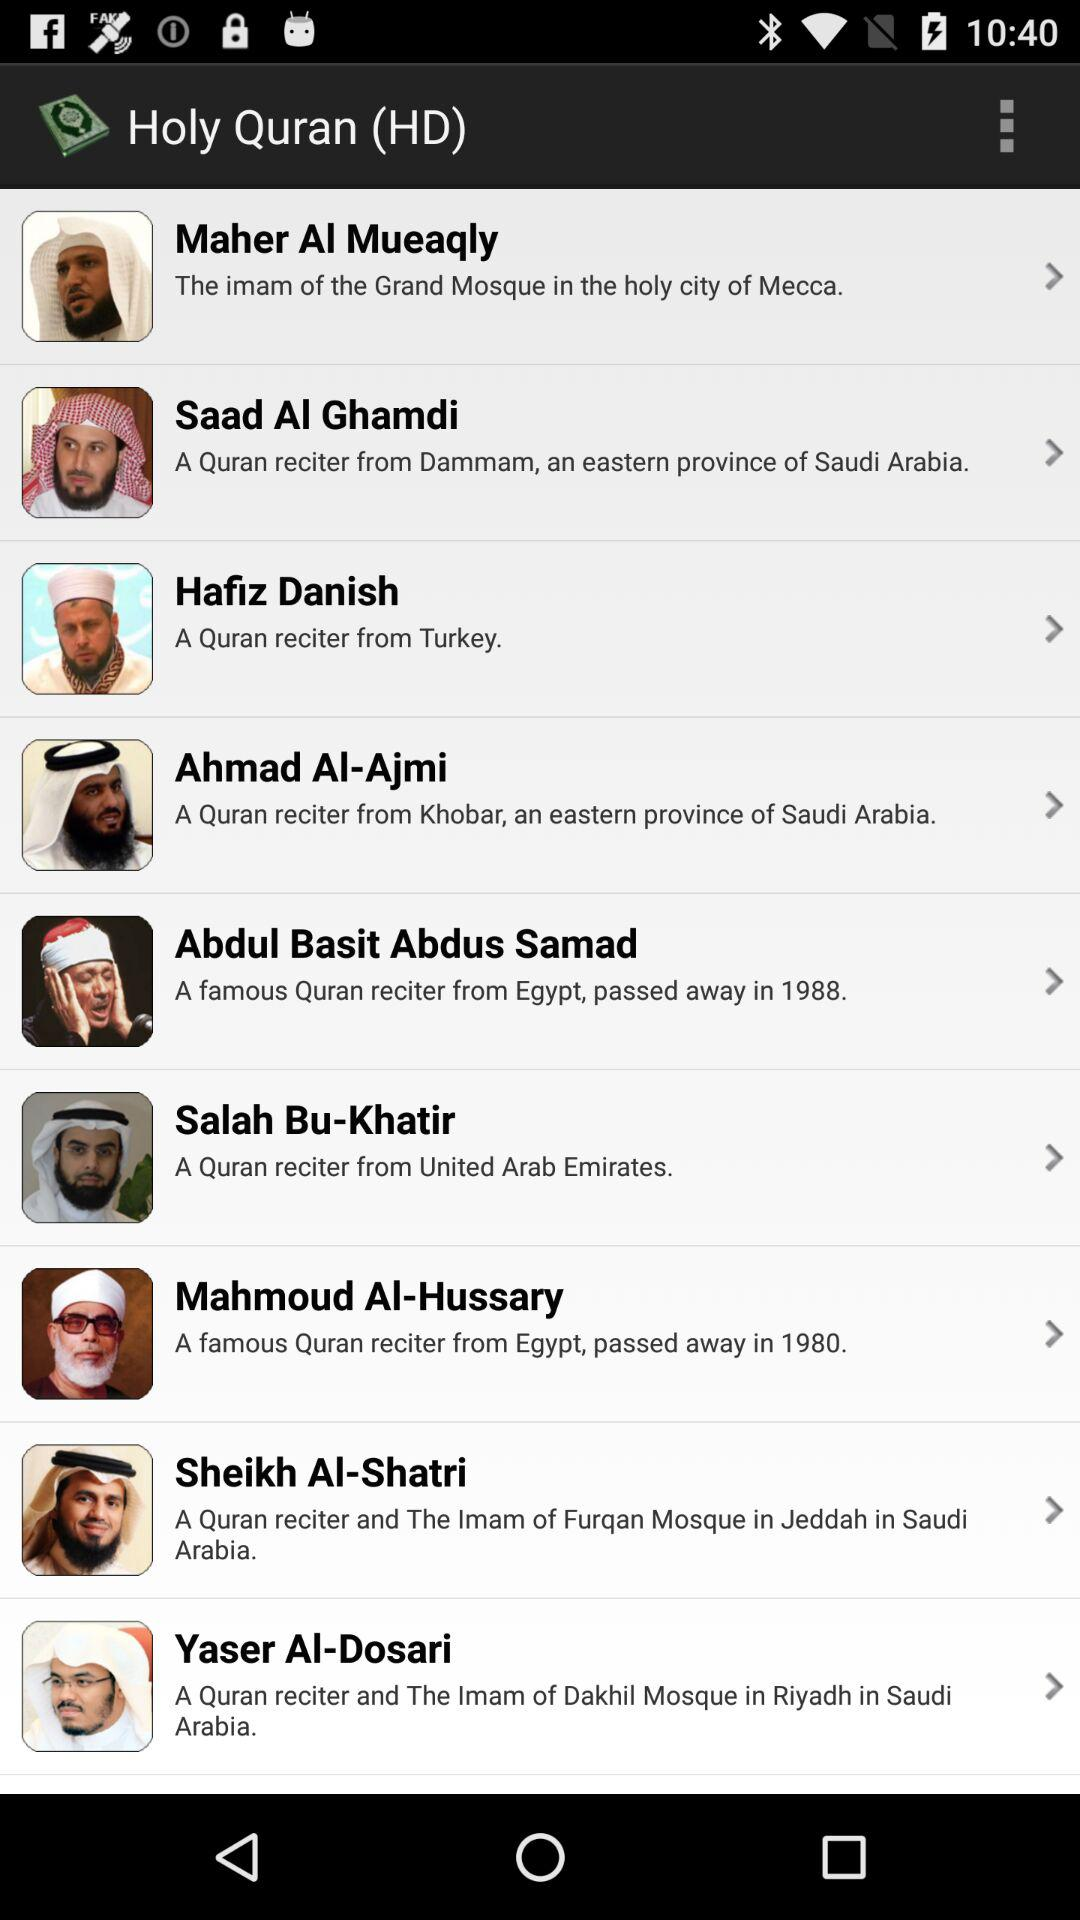How many reciters are from Saudi Arabia?
Answer the question using a single word or phrase. 4 